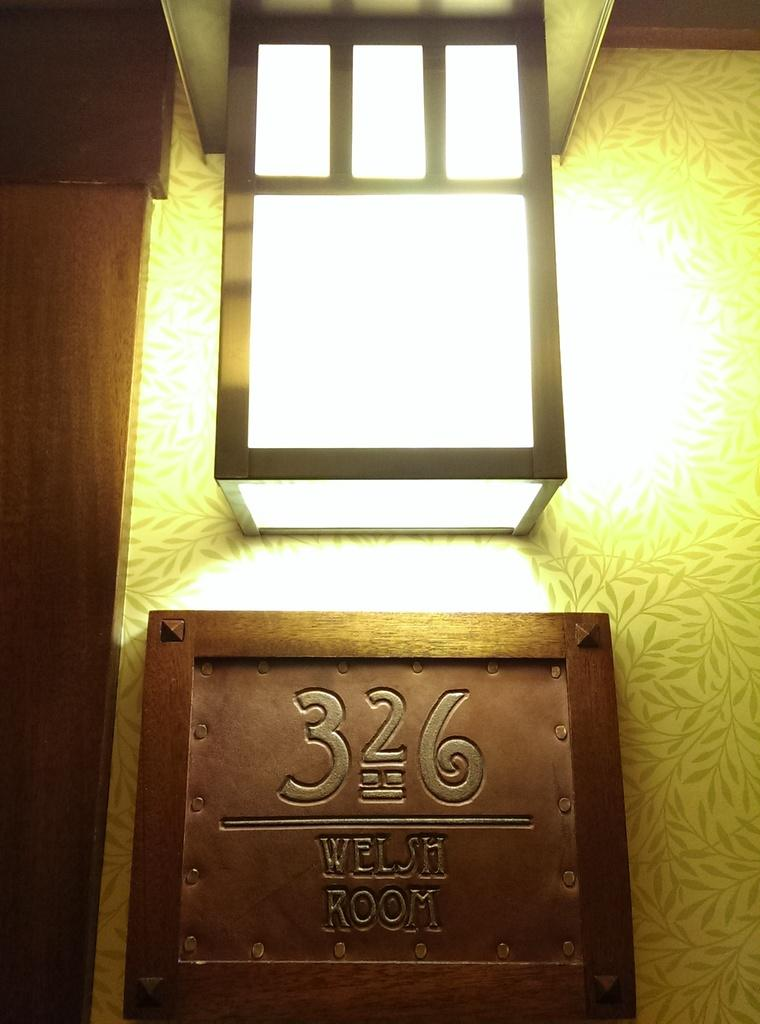What is the main source of light in the image? There is light in the middle of the image. What object is present in the image besides the light? There is a board in the image. What information is written on the board? The board has the text "326 WELSH ROOM" at the bottom. How many stitches are visible on the board in the image? There are no stitches visible on the board in the image. What type of crow can be seen perched on the light in the image? There is no crow present in the image; it only features light and a board. 